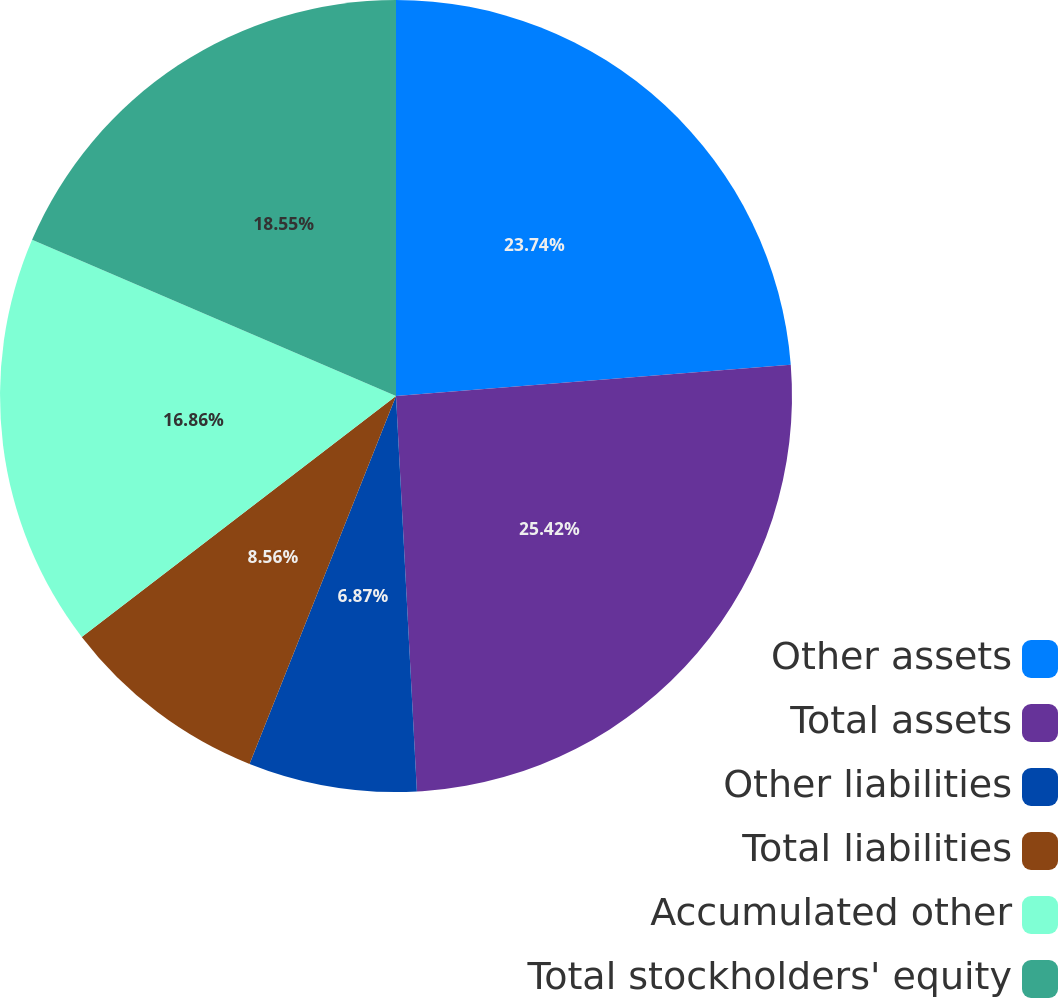Convert chart to OTSL. <chart><loc_0><loc_0><loc_500><loc_500><pie_chart><fcel>Other assets<fcel>Total assets<fcel>Other liabilities<fcel>Total liabilities<fcel>Accumulated other<fcel>Total stockholders' equity<nl><fcel>23.74%<fcel>25.42%<fcel>6.87%<fcel>8.56%<fcel>16.86%<fcel>18.55%<nl></chart> 